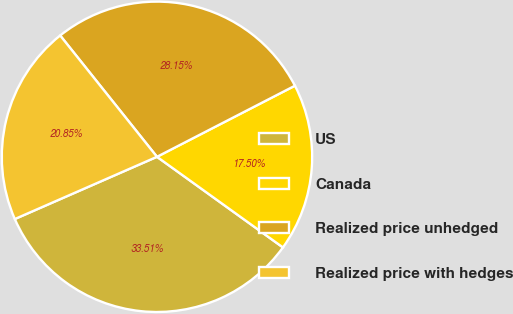<chart> <loc_0><loc_0><loc_500><loc_500><pie_chart><fcel>US<fcel>Canada<fcel>Realized price unhedged<fcel>Realized price with hedges<nl><fcel>33.51%<fcel>17.5%<fcel>28.15%<fcel>20.85%<nl></chart> 